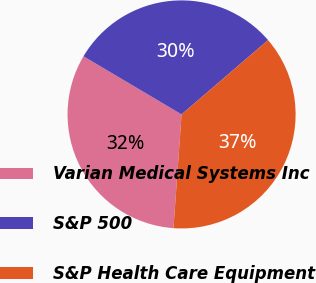Convert chart. <chart><loc_0><loc_0><loc_500><loc_500><pie_chart><fcel>Varian Medical Systems Inc<fcel>S&P 500<fcel>S&P Health Care Equipment<nl><fcel>32.38%<fcel>30.19%<fcel>37.43%<nl></chart> 